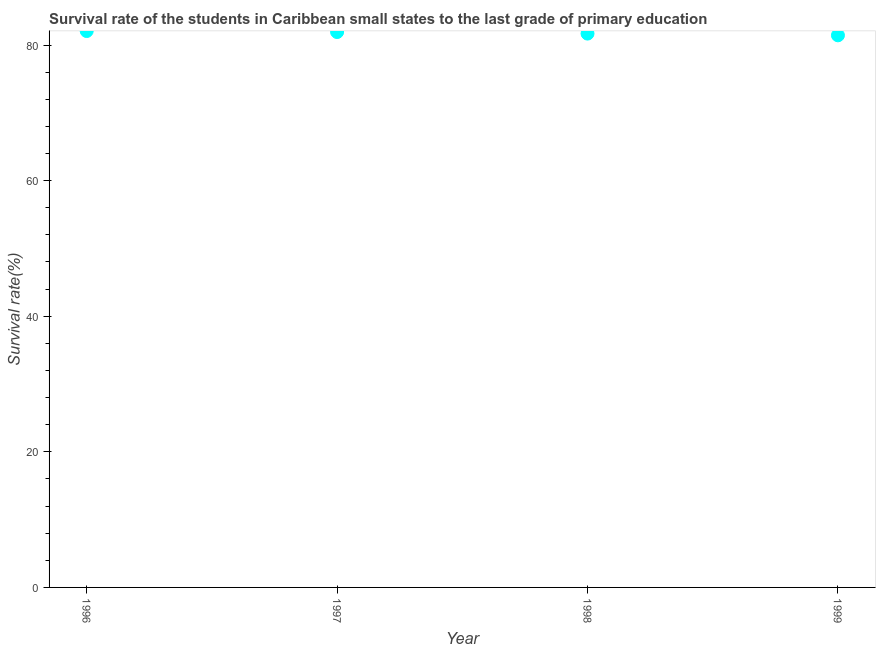What is the survival rate in primary education in 1999?
Ensure brevity in your answer.  81.43. Across all years, what is the maximum survival rate in primary education?
Offer a terse response. 82.06. Across all years, what is the minimum survival rate in primary education?
Ensure brevity in your answer.  81.43. In which year was the survival rate in primary education maximum?
Your response must be concise. 1996. What is the sum of the survival rate in primary education?
Offer a terse response. 327.09. What is the difference between the survival rate in primary education in 1998 and 1999?
Give a very brief answer. 0.26. What is the average survival rate in primary education per year?
Make the answer very short. 81.77. What is the median survival rate in primary education?
Your answer should be very brief. 81.8. In how many years, is the survival rate in primary education greater than 44 %?
Make the answer very short. 4. Do a majority of the years between 1999 and 1997 (inclusive) have survival rate in primary education greater than 32 %?
Make the answer very short. No. What is the ratio of the survival rate in primary education in 1998 to that in 1999?
Give a very brief answer. 1. What is the difference between the highest and the second highest survival rate in primary education?
Keep it short and to the point. 0.15. What is the difference between the highest and the lowest survival rate in primary education?
Offer a very short reply. 0.63. In how many years, is the survival rate in primary education greater than the average survival rate in primary education taken over all years?
Your answer should be very brief. 2. How many dotlines are there?
Provide a short and direct response. 1. What is the difference between two consecutive major ticks on the Y-axis?
Keep it short and to the point. 20. What is the title of the graph?
Make the answer very short. Survival rate of the students in Caribbean small states to the last grade of primary education. What is the label or title of the Y-axis?
Offer a terse response. Survival rate(%). What is the Survival rate(%) in 1996?
Ensure brevity in your answer.  82.06. What is the Survival rate(%) in 1997?
Provide a short and direct response. 81.91. What is the Survival rate(%) in 1998?
Your answer should be compact. 81.69. What is the Survival rate(%) in 1999?
Ensure brevity in your answer.  81.43. What is the difference between the Survival rate(%) in 1996 and 1997?
Ensure brevity in your answer.  0.15. What is the difference between the Survival rate(%) in 1996 and 1998?
Your answer should be very brief. 0.38. What is the difference between the Survival rate(%) in 1996 and 1999?
Your response must be concise. 0.63. What is the difference between the Survival rate(%) in 1997 and 1998?
Give a very brief answer. 0.23. What is the difference between the Survival rate(%) in 1997 and 1999?
Your answer should be very brief. 0.48. What is the difference between the Survival rate(%) in 1998 and 1999?
Give a very brief answer. 0.26. What is the ratio of the Survival rate(%) in 1996 to that in 1998?
Your answer should be compact. 1. What is the ratio of the Survival rate(%) in 1997 to that in 1999?
Provide a short and direct response. 1.01. 